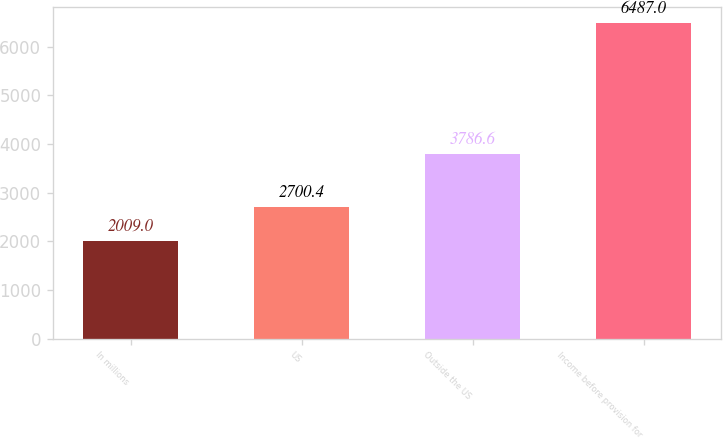<chart> <loc_0><loc_0><loc_500><loc_500><bar_chart><fcel>In millions<fcel>US<fcel>Outside the US<fcel>Income before provision for<nl><fcel>2009<fcel>2700.4<fcel>3786.6<fcel>6487<nl></chart> 